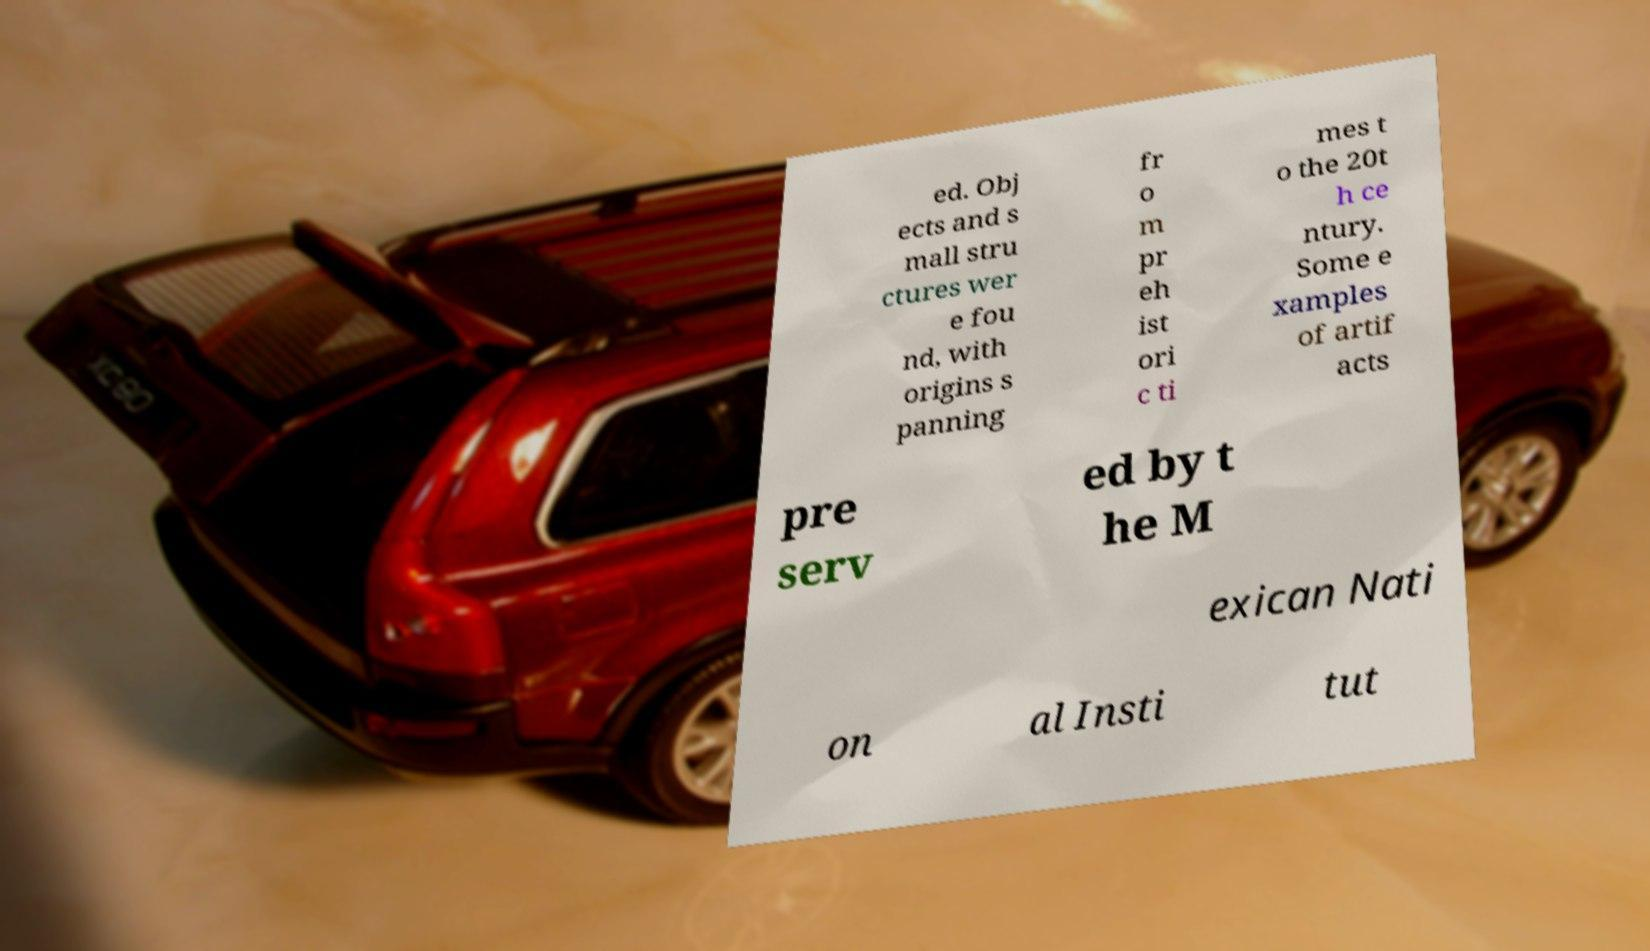What messages or text are displayed in this image? I need them in a readable, typed format. ed. Obj ects and s mall stru ctures wer e fou nd, with origins s panning fr o m pr eh ist ori c ti mes t o the 20t h ce ntury. Some e xamples of artif acts pre serv ed by t he M exican Nati on al Insti tut 